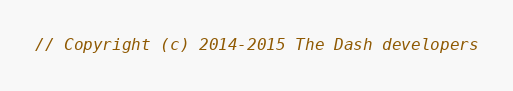Convert code to text. <code><loc_0><loc_0><loc_500><loc_500><_C_>// Copyright (c) 2014-2015 The Dash developers</code> 